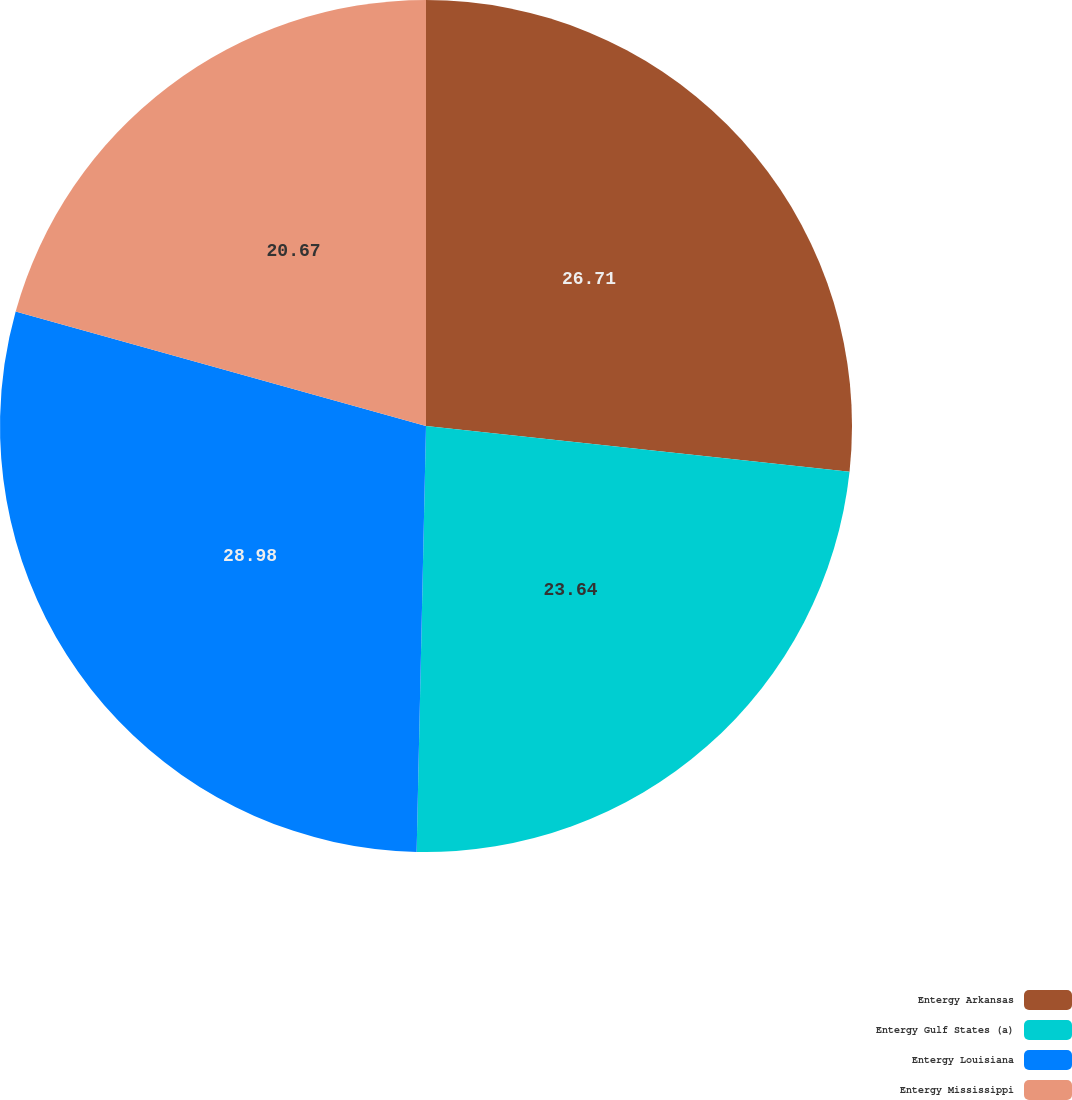<chart> <loc_0><loc_0><loc_500><loc_500><pie_chart><fcel>Entergy Arkansas<fcel>Entergy Gulf States (a)<fcel>Entergy Louisiana<fcel>Entergy Mississippi<nl><fcel>26.71%<fcel>23.64%<fcel>28.98%<fcel>20.67%<nl></chart> 